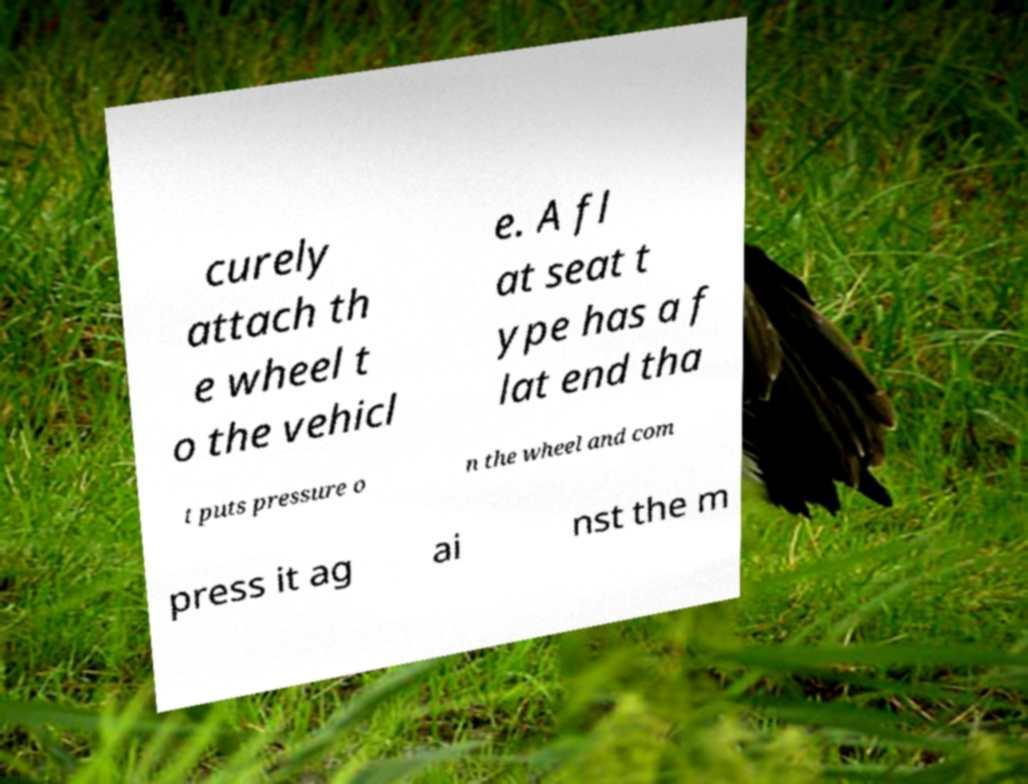Can you read and provide the text displayed in the image?This photo seems to have some interesting text. Can you extract and type it out for me? curely attach th e wheel t o the vehicl e. A fl at seat t ype has a f lat end tha t puts pressure o n the wheel and com press it ag ai nst the m 